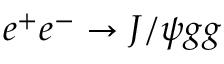<formula> <loc_0><loc_0><loc_500><loc_500>e ^ { + } e ^ { - } \to J / \psi g g</formula> 